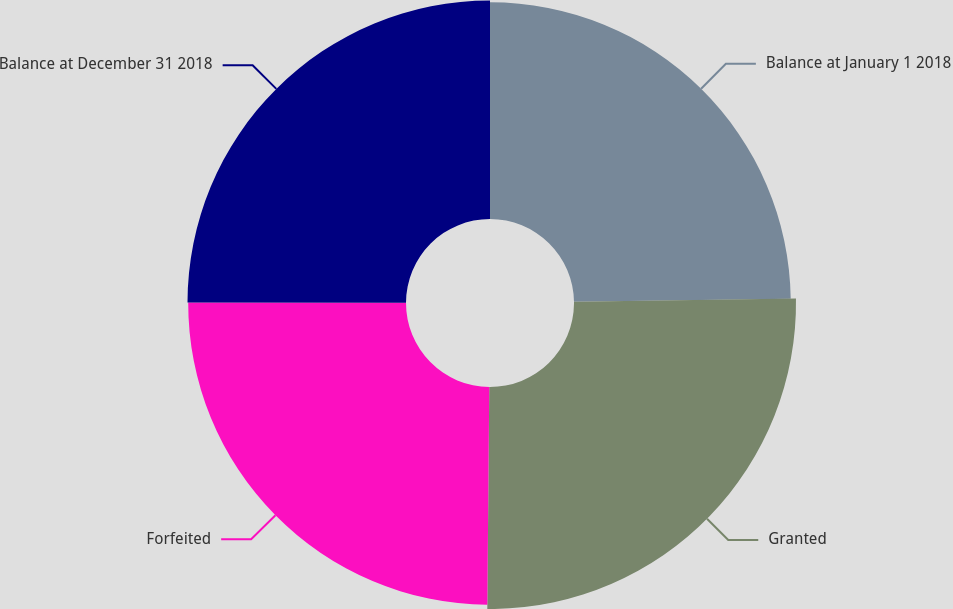Convert chart to OTSL. <chart><loc_0><loc_0><loc_500><loc_500><pie_chart><fcel>Balance at January 1 2018<fcel>Granted<fcel>Forfeited<fcel>Balance at December 31 2018<nl><fcel>24.77%<fcel>25.37%<fcel>24.89%<fcel>24.97%<nl></chart> 